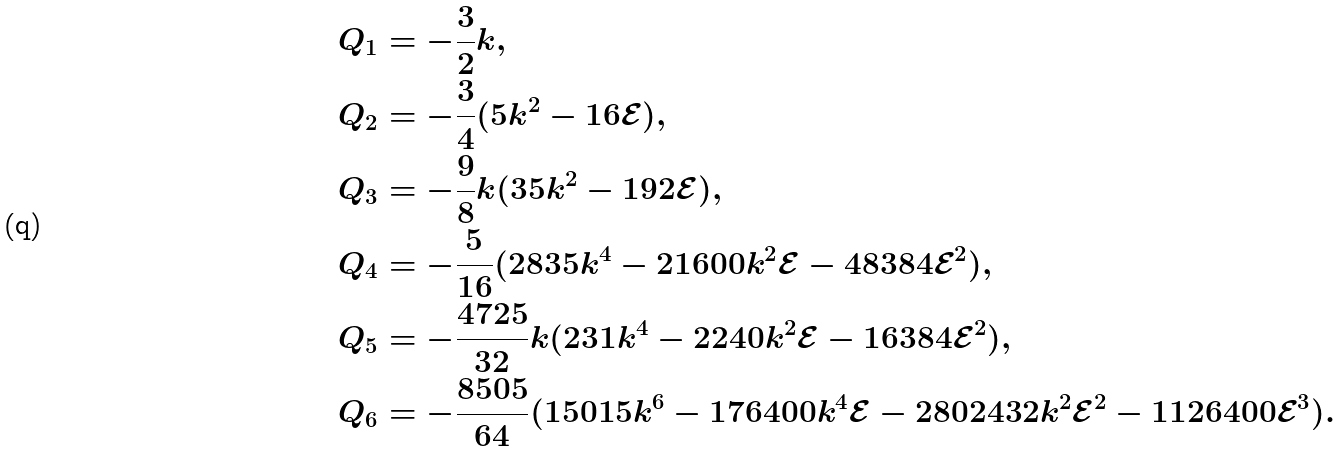<formula> <loc_0><loc_0><loc_500><loc_500>Q _ { 1 } & = - \frac { 3 } { 2 } k , \\ Q _ { 2 } & = - \frac { 3 } { 4 } ( 5 k ^ { 2 } - 1 6 \mathcal { E } ) , \\ Q _ { 3 } & = - \frac { 9 } { 8 } k ( 3 5 k ^ { 2 } - 1 9 2 \mathcal { E } ) , \\ Q _ { 4 } & = - \frac { 5 } { 1 6 } ( 2 8 3 5 k ^ { 4 } - 2 1 6 0 0 k ^ { 2 } \mathcal { E } - 4 8 3 8 4 \mathcal { E } ^ { 2 } ) , \\ Q _ { 5 } & = - \frac { 4 7 2 5 } { 3 2 } k ( 2 3 1 k ^ { 4 } - 2 2 4 0 k ^ { 2 } \mathcal { E } - 1 6 3 8 4 \mathcal { E } ^ { 2 } ) , \\ Q _ { 6 } & = - \frac { 8 5 0 5 } { 6 4 } ( 1 5 0 1 5 k ^ { 6 } - 1 7 6 4 0 0 k ^ { 4 } \mathcal { E } - 2 8 0 2 4 3 2 k ^ { 2 } \mathcal { E } ^ { 2 } - 1 1 2 6 4 0 0 \mathcal { E } ^ { 3 } ) .</formula> 